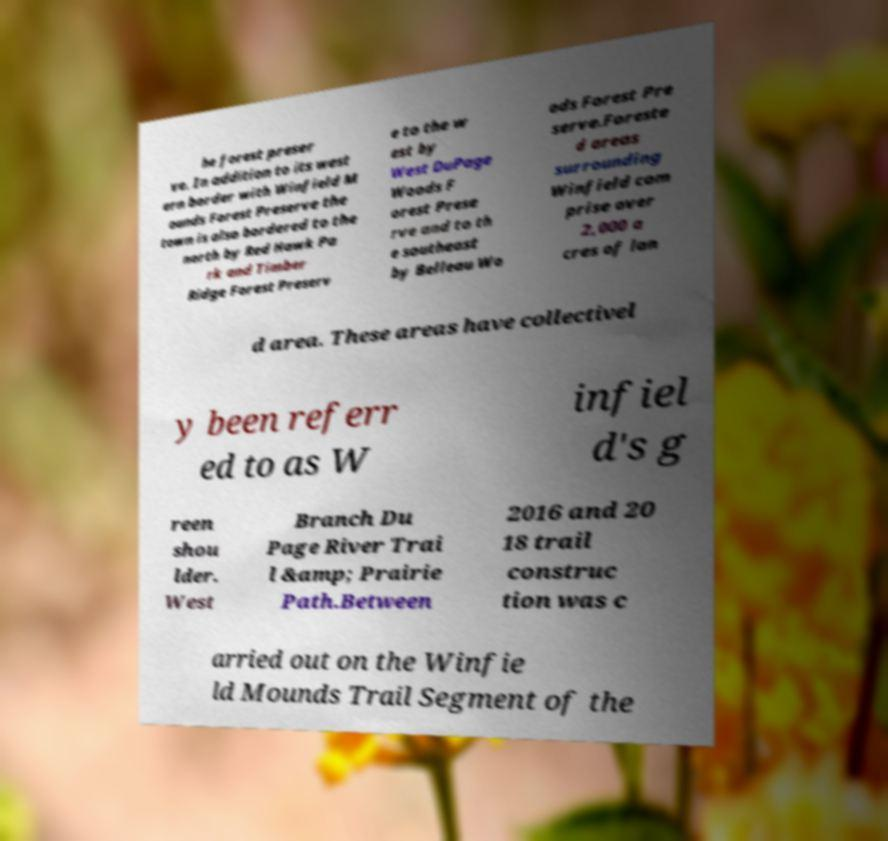For documentation purposes, I need the text within this image transcribed. Could you provide that? he forest preser ve. In addition to its west ern border with Winfield M ounds Forest Preserve the town is also bordered to the north by Red Hawk Pa rk and Timber Ridge Forest Preserv e to the w est by West DuPage Woods F orest Prese rve and to th e southeast by Belleau Wo ods Forest Pre serve.Foreste d areas surrounding Winfield com prise over 2,000 a cres of lan d area. These areas have collectivel y been referr ed to as W infiel d's g reen shou lder. West Branch Du Page River Trai l &amp; Prairie Path.Between 2016 and 20 18 trail construc tion was c arried out on the Winfie ld Mounds Trail Segment of the 